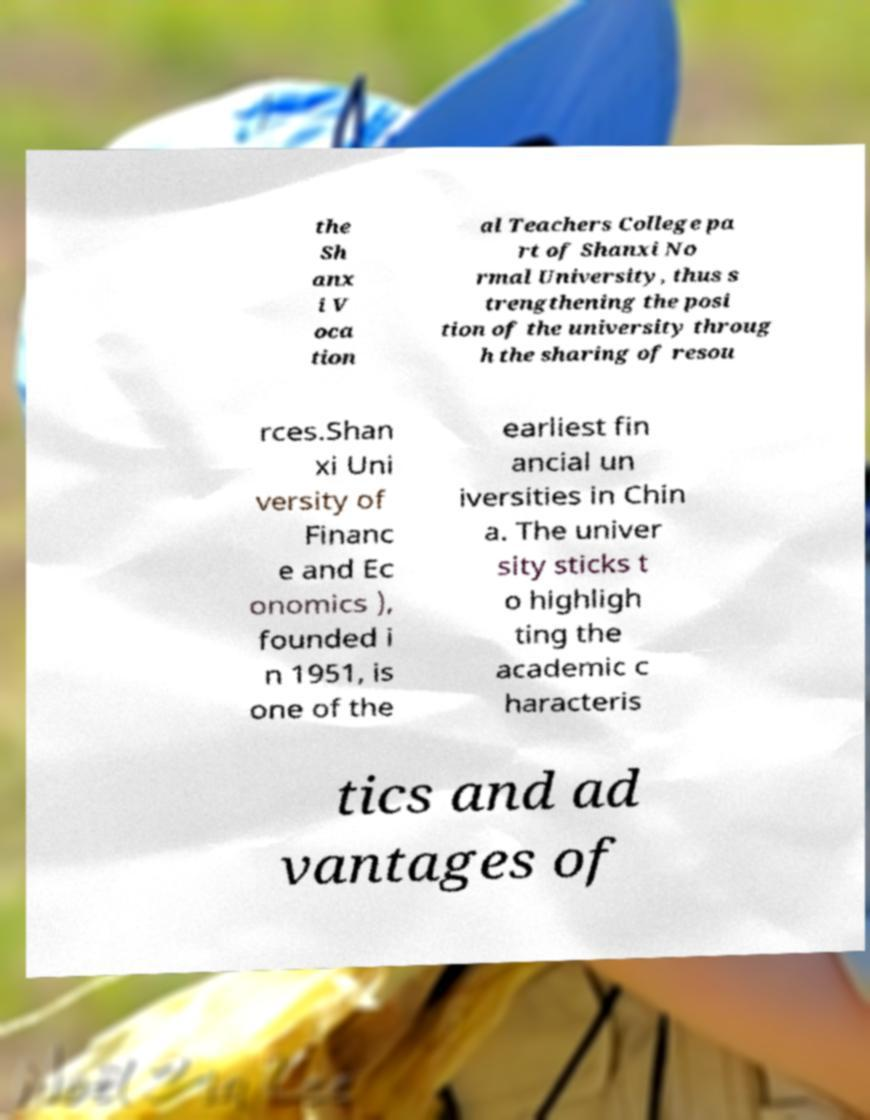Please read and relay the text visible in this image. What does it say? the Sh anx i V oca tion al Teachers College pa rt of Shanxi No rmal University, thus s trengthening the posi tion of the university throug h the sharing of resou rces.Shan xi Uni versity of Financ e and Ec onomics ), founded i n 1951, is one of the earliest fin ancial un iversities in Chin a. The univer sity sticks t o highligh ting the academic c haracteris tics and ad vantages of 